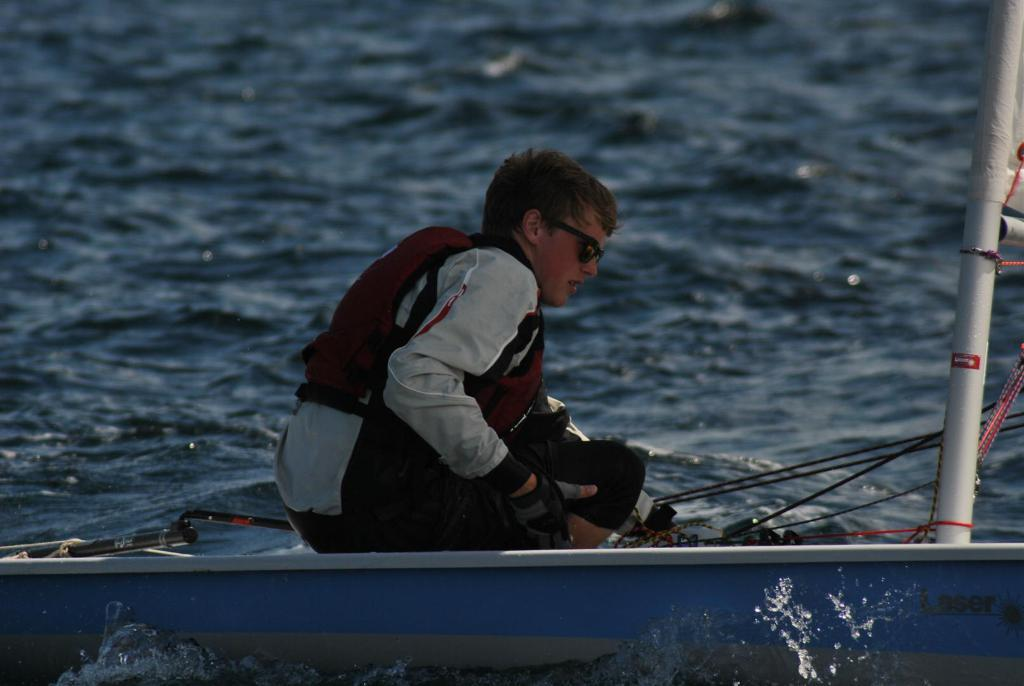What is the main subject of the image? The main subject of the image is a boat. Where is the boat located in the image? The boat is on the water surface in the image. Is there anyone on the boat? Yes, there is a man sitting on the boat. How many balls can be seen floating in the water near the boat? There are no balls visible in the image; it only features a boat on the water surface with a man sitting on it. 